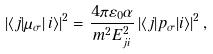Convert formula to latex. <formula><loc_0><loc_0><loc_500><loc_500>\left | \langle j | \mu _ { \sigma } \right | i \rangle | ^ { 2 } = \frac { 4 \pi \varepsilon _ { 0 } \alpha } { m ^ { 2 } E _ { j i } ^ { 2 } } \left | \langle j | { p } _ { \sigma } | i \rangle \right | ^ { 2 } ,</formula> 